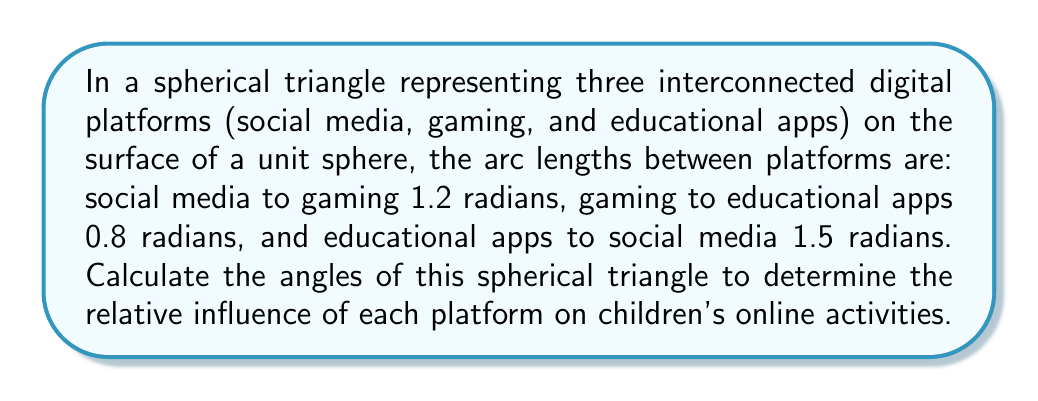Provide a solution to this math problem. To solve this problem, we'll use the spherical law of cosines. For a spherical triangle with sides a, b, and c, and opposite angles A, B, and C, the law states:

$$\cos(a) = \cos(b)\cos(c) + \sin(b)\sin(c)\cos(A)$$

Let's assign:
a = 1.5 (educational apps to social media)
b = 1.2 (social media to gaming)
c = 0.8 (gaming to educational apps)

Step 1: Calculate angle A (opposite to side a)
$$\cos(1.5) = \cos(1.2)\cos(0.8) + \sin(1.2)\sin(0.8)\cos(A)$$
$$0.0707 = 0.3675 + 0.7651\cos(A)$$
$$\cos(A) = \frac{0.0707 - 0.3675}{0.7651} = -0.3880$$
$$A = \arccos(-0.3880) = 1.9634 \text{ radians}$$

Step 2: Calculate angle B (opposite to side b)
$$\cos(1.2) = \cos(1.5)\cos(0.8) + \sin(1.5)\sin(0.8)\cos(B)$$
$$0.3624 = 0.0502 + 0.9308\cos(B)$$
$$\cos(B) = \frac{0.3624 - 0.0502}{0.9308} = 0.3355$$
$$B = \arccos(0.3355) = 1.2309 \text{ radians}$$

Step 3: Calculate angle C (opposite to side c)
$$\cos(0.8) = \cos(1.5)\cos(1.2) + \sin(1.5)\sin(1.2)\cos(C)$$
$$0.6967 = 0.0256 + 0.9744\cos(C)$$
$$\cos(C) = \frac{0.6967 - 0.0256}{0.9744} = 0.6889$$
$$C = \arccos(0.6889) = 0.8127 \text{ radians}$$

Step 4: Convert radians to degrees
A = 1.9634 * (180/π) ≈ 112.5°
B = 1.2309 * (180/π) ≈ 70.5°
C = 0.8127 * (180/π) ≈ 46.6°
Answer: A ≈ 112.5°, B ≈ 70.5°, C ≈ 46.6° 